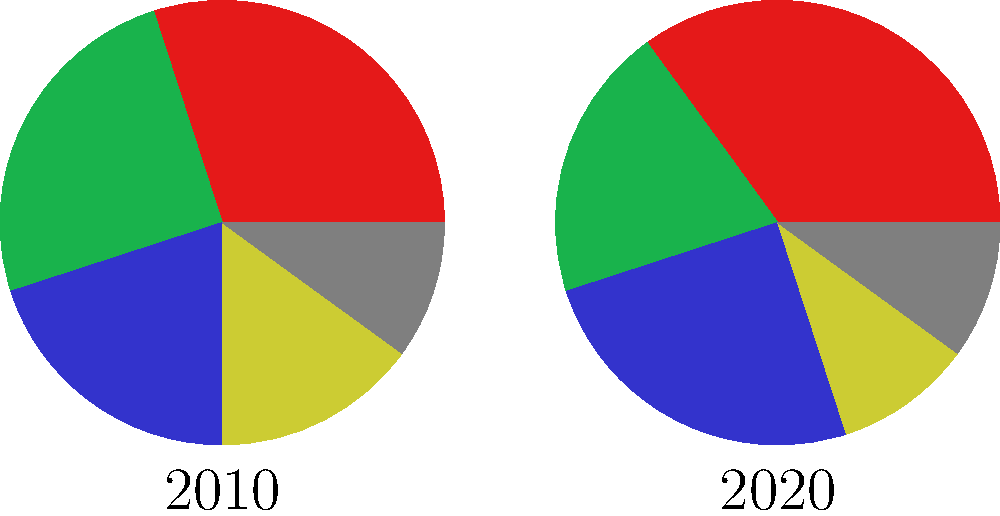The pie charts show the distribution of immigrant populations in South Africa for the years 2010 and 2020. What is the most significant change in the demographic composition of immigrants between these two years? To determine the most significant change in the demographic composition of immigrants between 2010 and 2020, we need to compare the percentages for each region in both years:

1. East Asia:
   2010: 30%, 2020: 35%
   Change: +5%

2. South Asia:
   2010: 25%, 2020: 20%
   Change: -5%

3. Africa:
   2010: 20%, 2020: 25%
   Change: +5%

4. Europe:
   2010: 15%, 2020: 10%
   Change: -5%

5. Other:
   2010: 10%, 2020: 10%
   Change: 0%

The most significant changes are:
a) Increase in East Asian immigrants by 5%
b) Increase in African immigrants by 5%
c) Decrease in South Asian immigrants by 5%
d) Decrease in European immigrants by 5%

While the magnitude of change is the same for these four groups, the most notable shift is the increase in East Asian immigrants, as they have become the largest group in 2020, surpassing South Asian immigrants.
Answer: Increase in East Asian immigrants by 5%, becoming the largest group. 